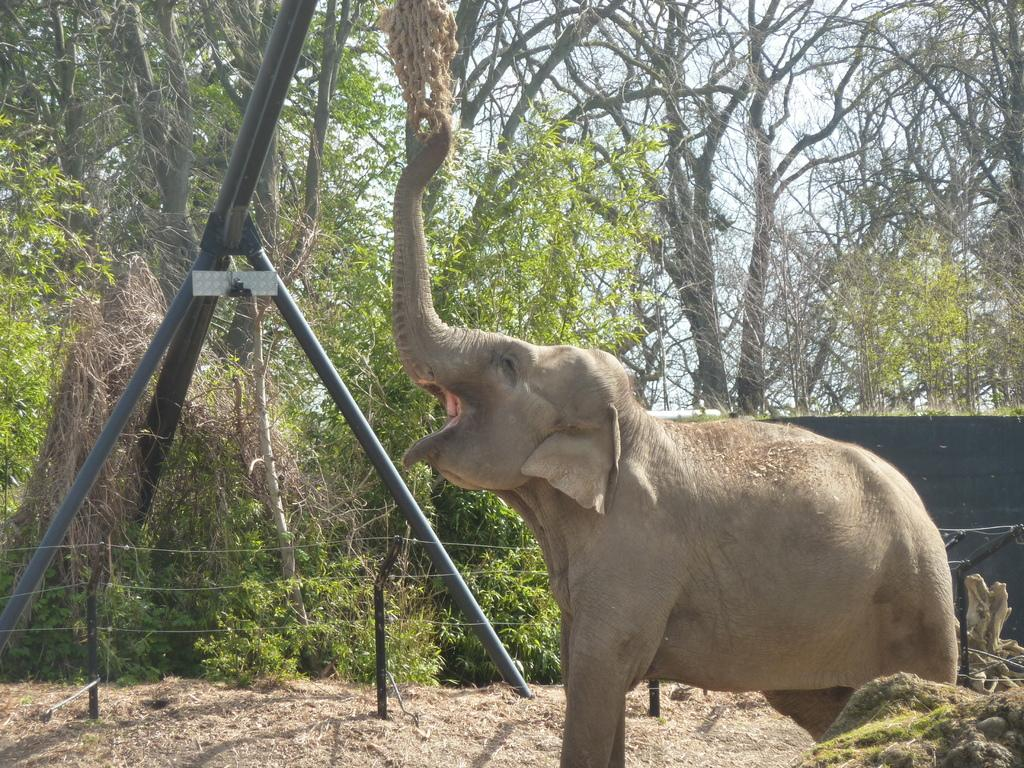What type of animal can be seen in the image? There is an elephant in the image. What type of vegetation is present in the image? There is grass in the image. What type of construction material is visible in the image? Iron rods are present in the image. What type of barrier can be seen in the image? There is a fence in the image. What type of natural feature is visible in the image? Trees are visible in the image. What type of objects are present in the image? There are objects in the image. What is visible in the background of the image? The sky is visible in the background of the image. What time of day is it in the image? The time of day cannot be determined from the image alone, as there are no specific indicators of time. 